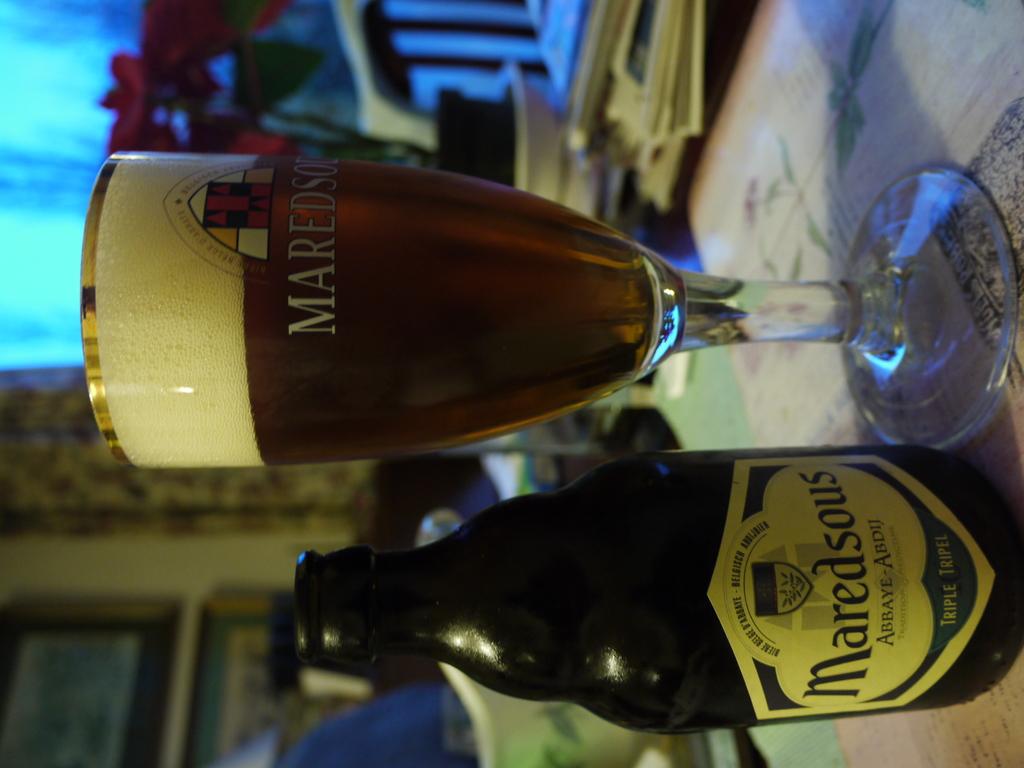What is the brand name?
Give a very brief answer. Maredsous. 